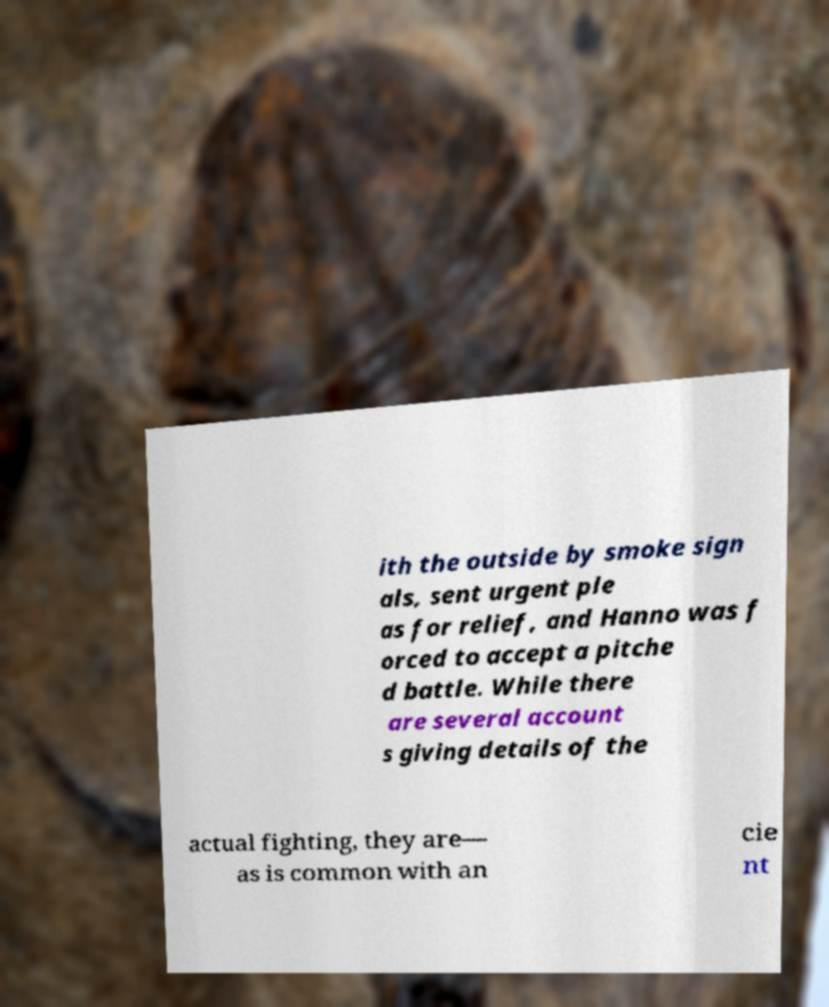Please identify and transcribe the text found in this image. ith the outside by smoke sign als, sent urgent ple as for relief, and Hanno was f orced to accept a pitche d battle. While there are several account s giving details of the actual fighting, they are— as is common with an cie nt 